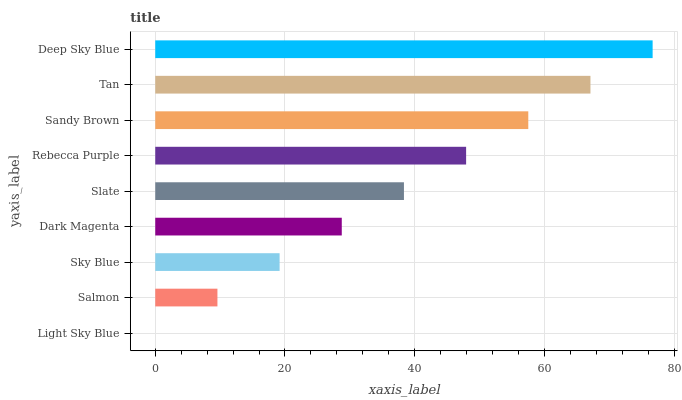Is Light Sky Blue the minimum?
Answer yes or no. Yes. Is Deep Sky Blue the maximum?
Answer yes or no. Yes. Is Salmon the minimum?
Answer yes or no. No. Is Salmon the maximum?
Answer yes or no. No. Is Salmon greater than Light Sky Blue?
Answer yes or no. Yes. Is Light Sky Blue less than Salmon?
Answer yes or no. Yes. Is Light Sky Blue greater than Salmon?
Answer yes or no. No. Is Salmon less than Light Sky Blue?
Answer yes or no. No. Is Slate the high median?
Answer yes or no. Yes. Is Slate the low median?
Answer yes or no. Yes. Is Deep Sky Blue the high median?
Answer yes or no. No. Is Deep Sky Blue the low median?
Answer yes or no. No. 